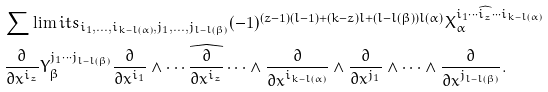<formula> <loc_0><loc_0><loc_500><loc_500>& \sum \lim i t s _ { i _ { 1 } , \dots , i _ { k - l ( \alpha ) } , j _ { 1 } , \dots , j _ { l - l ( \beta ) } } ( - 1 ) ^ { ( z - 1 ) ( l - 1 ) + ( k - z ) l + ( l - l ( \beta ) ) l ( \alpha ) } X _ { \alpha } ^ { i _ { 1 } \cdots \widehat { i _ { z } } \cdots i _ { k - l ( \alpha ) } } \\ & \frac { \partial } { \partial x ^ { i _ { z } } } Y _ { \beta } ^ { j _ { 1 } \cdots j _ { l - l ( \beta ) } } \frac { \partial } { \partial x ^ { i _ { 1 } } } \wedge \cdots \widehat { \frac { \partial } { \partial x ^ { i _ { z } } } } \cdots \wedge \frac { \partial } { \partial x ^ { i _ { k - l ( \alpha ) } } } \wedge \frac { \partial } { \partial x ^ { j _ { 1 } } } \wedge \cdots \wedge \frac { \partial } { \partial x ^ { j _ { l - l ( \beta ) } } } .</formula> 